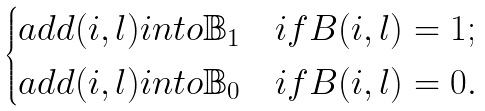Convert formula to latex. <formula><loc_0><loc_0><loc_500><loc_500>\begin{cases} a d d ( i , l ) i n t o \mathbb { B } _ { 1 } & i f B ( i , l ) = 1 ; \\ a d d ( i , l ) i n t o \mathbb { B } _ { 0 } & i f B ( i , l ) = 0 . \end{cases}</formula> 